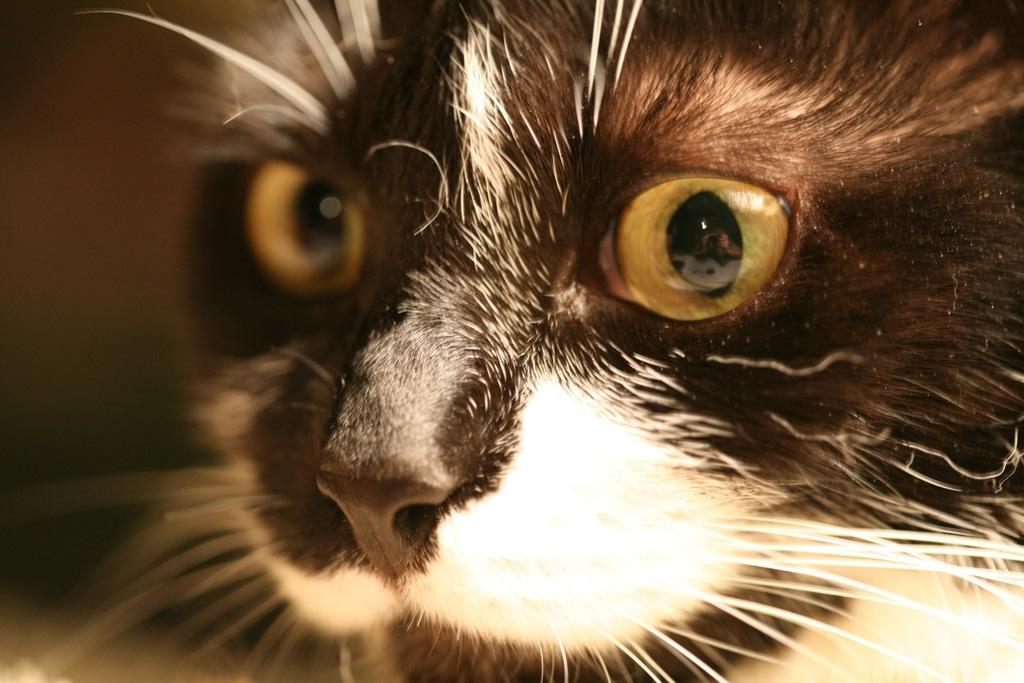What type of animal is in the image? There is a cat in the image. What type of mask is the cat wearing in the image? There is no mask present in the image; the cat is not wearing any type of mask. 